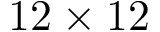<formula> <loc_0><loc_0><loc_500><loc_500>1 2 \times 1 2</formula> 